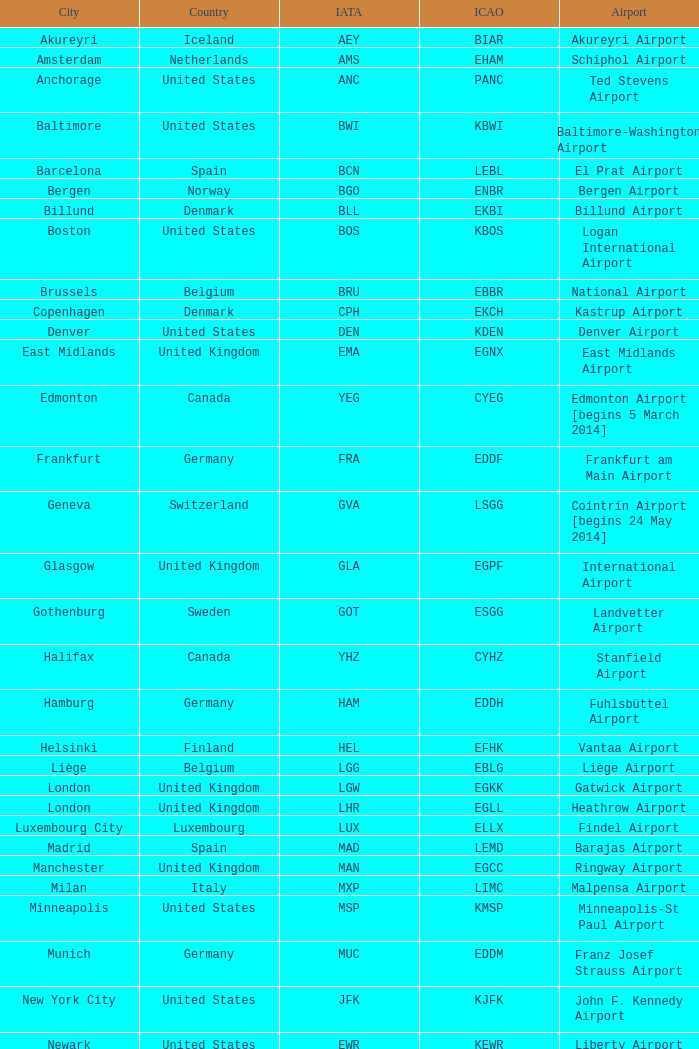What is the Airport with the ICAO fo KSEA? Seattle–Tacoma Airport. 